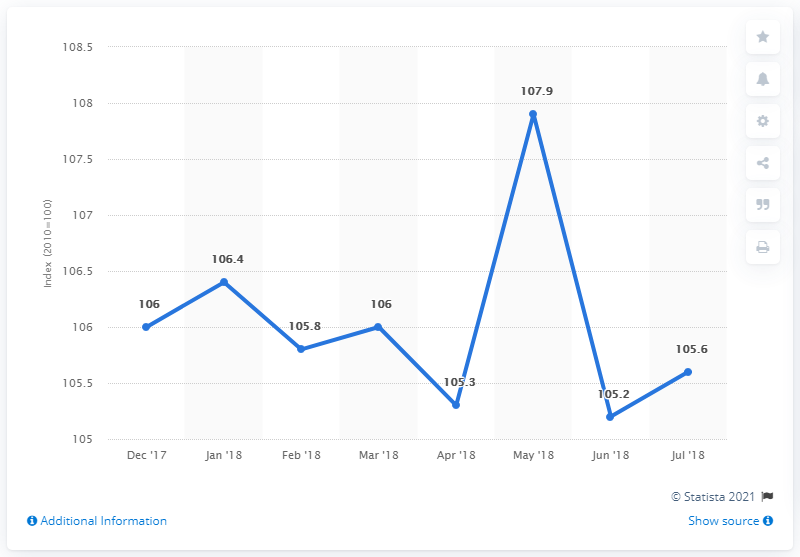Identify some key points in this picture. In May 2018, the value of retail trade sales in Finland was 107.9. 